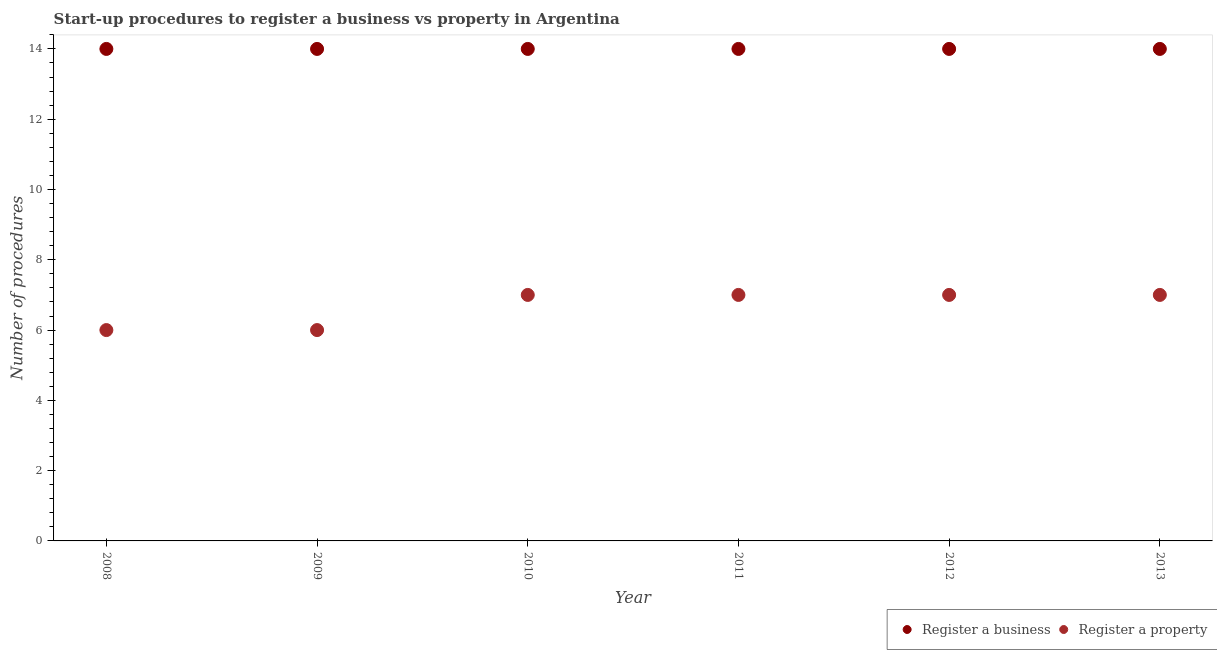What is the number of procedures to register a business in 2012?
Your answer should be very brief. 14. Across all years, what is the maximum number of procedures to register a business?
Your response must be concise. 14. Across all years, what is the minimum number of procedures to register a business?
Your answer should be very brief. 14. In which year was the number of procedures to register a business minimum?
Ensure brevity in your answer.  2008. What is the total number of procedures to register a property in the graph?
Give a very brief answer. 40. What is the difference between the number of procedures to register a property in 2010 and the number of procedures to register a business in 2012?
Give a very brief answer. -7. What is the average number of procedures to register a property per year?
Your response must be concise. 6.67. In the year 2010, what is the difference between the number of procedures to register a business and number of procedures to register a property?
Ensure brevity in your answer.  7. In how many years, is the number of procedures to register a business greater than 2.8?
Provide a short and direct response. 6. What is the ratio of the number of procedures to register a property in 2008 to that in 2013?
Provide a short and direct response. 0.86. What is the difference between the highest and the second highest number of procedures to register a business?
Make the answer very short. 0. Is the sum of the number of procedures to register a business in 2010 and 2011 greater than the maximum number of procedures to register a property across all years?
Ensure brevity in your answer.  Yes. Does the number of procedures to register a property monotonically increase over the years?
Provide a succinct answer. No. Is the number of procedures to register a business strictly greater than the number of procedures to register a property over the years?
Offer a terse response. Yes. Is the number of procedures to register a business strictly less than the number of procedures to register a property over the years?
Your response must be concise. No. How many dotlines are there?
Make the answer very short. 2. How many years are there in the graph?
Keep it short and to the point. 6. Where does the legend appear in the graph?
Offer a very short reply. Bottom right. What is the title of the graph?
Your response must be concise. Start-up procedures to register a business vs property in Argentina. Does "Netherlands" appear as one of the legend labels in the graph?
Offer a terse response. No. What is the label or title of the Y-axis?
Ensure brevity in your answer.  Number of procedures. What is the Number of procedures in Register a business in 2009?
Keep it short and to the point. 14. What is the Number of procedures in Register a property in 2009?
Make the answer very short. 6. What is the Number of procedures in Register a property in 2010?
Make the answer very short. 7. What is the Number of procedures in Register a business in 2011?
Provide a succinct answer. 14. What is the Number of procedures in Register a property in 2011?
Offer a terse response. 7. What is the Number of procedures in Register a business in 2012?
Give a very brief answer. 14. What is the Number of procedures of Register a property in 2012?
Make the answer very short. 7. Across all years, what is the maximum Number of procedures of Register a property?
Your response must be concise. 7. What is the total Number of procedures of Register a property in the graph?
Ensure brevity in your answer.  40. What is the difference between the Number of procedures of Register a business in 2008 and that in 2010?
Ensure brevity in your answer.  0. What is the difference between the Number of procedures of Register a property in 2008 and that in 2010?
Provide a short and direct response. -1. What is the difference between the Number of procedures in Register a property in 2008 and that in 2011?
Your response must be concise. -1. What is the difference between the Number of procedures in Register a business in 2008 and that in 2012?
Provide a succinct answer. 0. What is the difference between the Number of procedures of Register a property in 2008 and that in 2013?
Keep it short and to the point. -1. What is the difference between the Number of procedures of Register a business in 2009 and that in 2011?
Your answer should be compact. 0. What is the difference between the Number of procedures in Register a business in 2009 and that in 2013?
Your response must be concise. 0. What is the difference between the Number of procedures of Register a property in 2009 and that in 2013?
Provide a succinct answer. -1. What is the difference between the Number of procedures of Register a business in 2011 and that in 2013?
Your answer should be very brief. 0. What is the difference between the Number of procedures of Register a business in 2012 and that in 2013?
Offer a terse response. 0. What is the difference between the Number of procedures of Register a business in 2008 and the Number of procedures of Register a property in 2010?
Your response must be concise. 7. What is the difference between the Number of procedures in Register a business in 2008 and the Number of procedures in Register a property in 2013?
Provide a succinct answer. 7. What is the difference between the Number of procedures of Register a business in 2009 and the Number of procedures of Register a property in 2010?
Ensure brevity in your answer.  7. What is the difference between the Number of procedures of Register a business in 2010 and the Number of procedures of Register a property in 2011?
Offer a very short reply. 7. What is the difference between the Number of procedures of Register a business in 2010 and the Number of procedures of Register a property in 2012?
Provide a short and direct response. 7. What is the difference between the Number of procedures of Register a business in 2010 and the Number of procedures of Register a property in 2013?
Your answer should be very brief. 7. What is the difference between the Number of procedures in Register a business in 2011 and the Number of procedures in Register a property in 2012?
Your answer should be very brief. 7. What is the average Number of procedures in Register a property per year?
Provide a succinct answer. 6.67. In the year 2011, what is the difference between the Number of procedures of Register a business and Number of procedures of Register a property?
Make the answer very short. 7. In the year 2012, what is the difference between the Number of procedures in Register a business and Number of procedures in Register a property?
Your answer should be very brief. 7. In the year 2013, what is the difference between the Number of procedures of Register a business and Number of procedures of Register a property?
Your response must be concise. 7. What is the ratio of the Number of procedures of Register a property in 2008 to that in 2009?
Give a very brief answer. 1. What is the ratio of the Number of procedures in Register a property in 2008 to that in 2010?
Your answer should be very brief. 0.86. What is the ratio of the Number of procedures of Register a business in 2008 to that in 2011?
Give a very brief answer. 1. What is the ratio of the Number of procedures in Register a property in 2008 to that in 2012?
Offer a terse response. 0.86. What is the ratio of the Number of procedures in Register a property in 2008 to that in 2013?
Your response must be concise. 0.86. What is the ratio of the Number of procedures of Register a property in 2009 to that in 2010?
Make the answer very short. 0.86. What is the ratio of the Number of procedures of Register a property in 2009 to that in 2011?
Provide a succinct answer. 0.86. What is the ratio of the Number of procedures in Register a property in 2009 to that in 2012?
Your answer should be very brief. 0.86. What is the ratio of the Number of procedures in Register a business in 2009 to that in 2013?
Offer a very short reply. 1. What is the ratio of the Number of procedures in Register a property in 2010 to that in 2011?
Provide a succinct answer. 1. What is the ratio of the Number of procedures of Register a business in 2010 to that in 2013?
Keep it short and to the point. 1. What is the ratio of the Number of procedures in Register a business in 2012 to that in 2013?
Offer a very short reply. 1. What is the ratio of the Number of procedures in Register a property in 2012 to that in 2013?
Offer a terse response. 1. What is the difference between the highest and the lowest Number of procedures in Register a business?
Your answer should be compact. 0. 